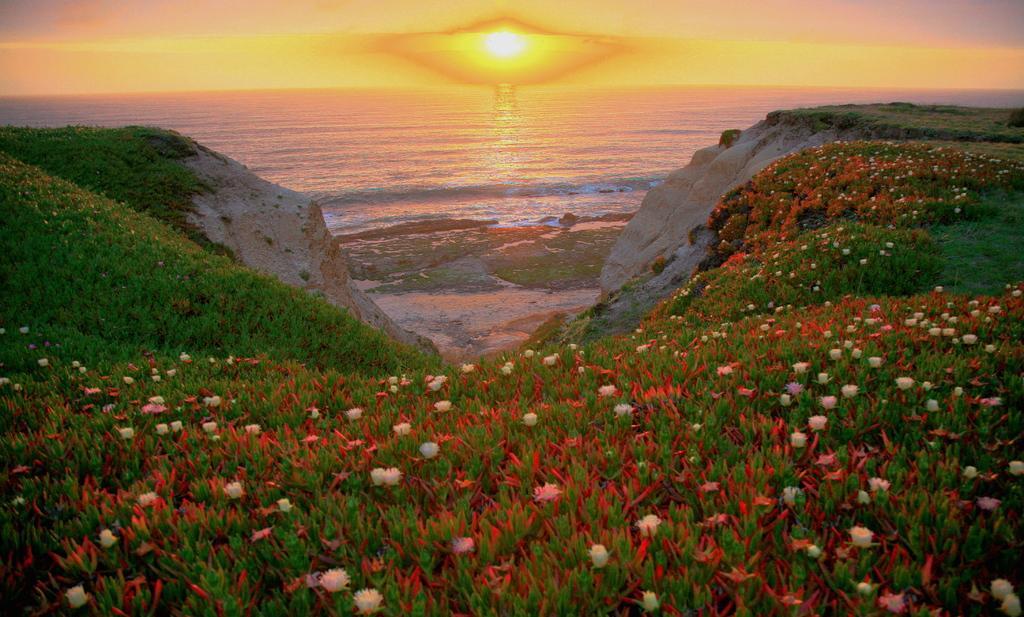Can you describe this image briefly? In this image there are plants, flowers, river and the sky. 